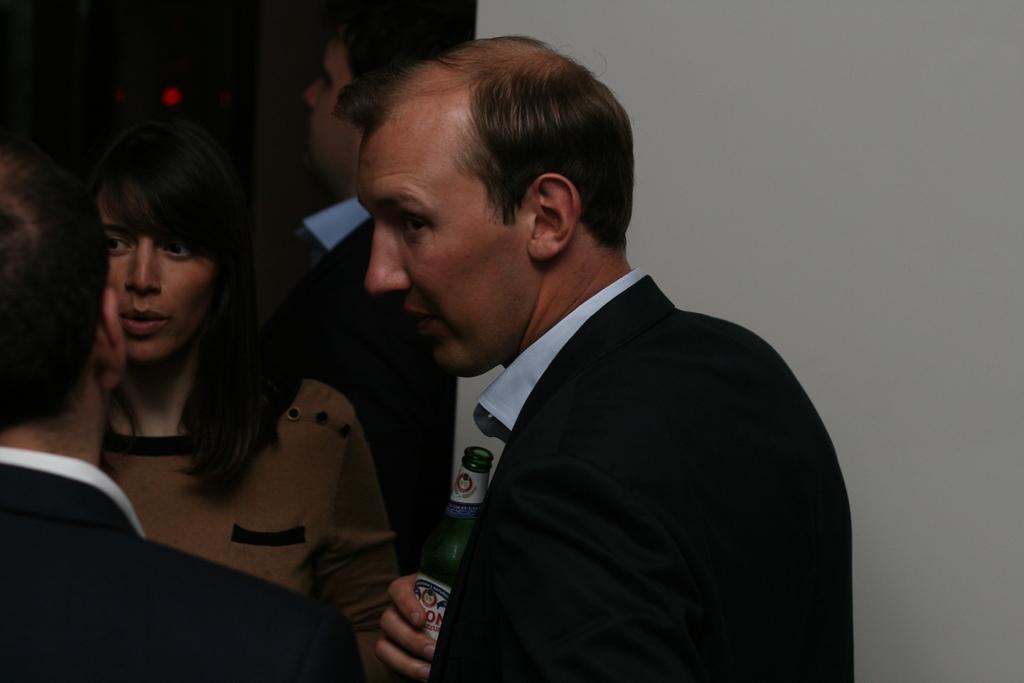How would you summarize this image in a sentence or two? Left a man and woman are standing and talking. On the right a man is holding a beer bottle. 